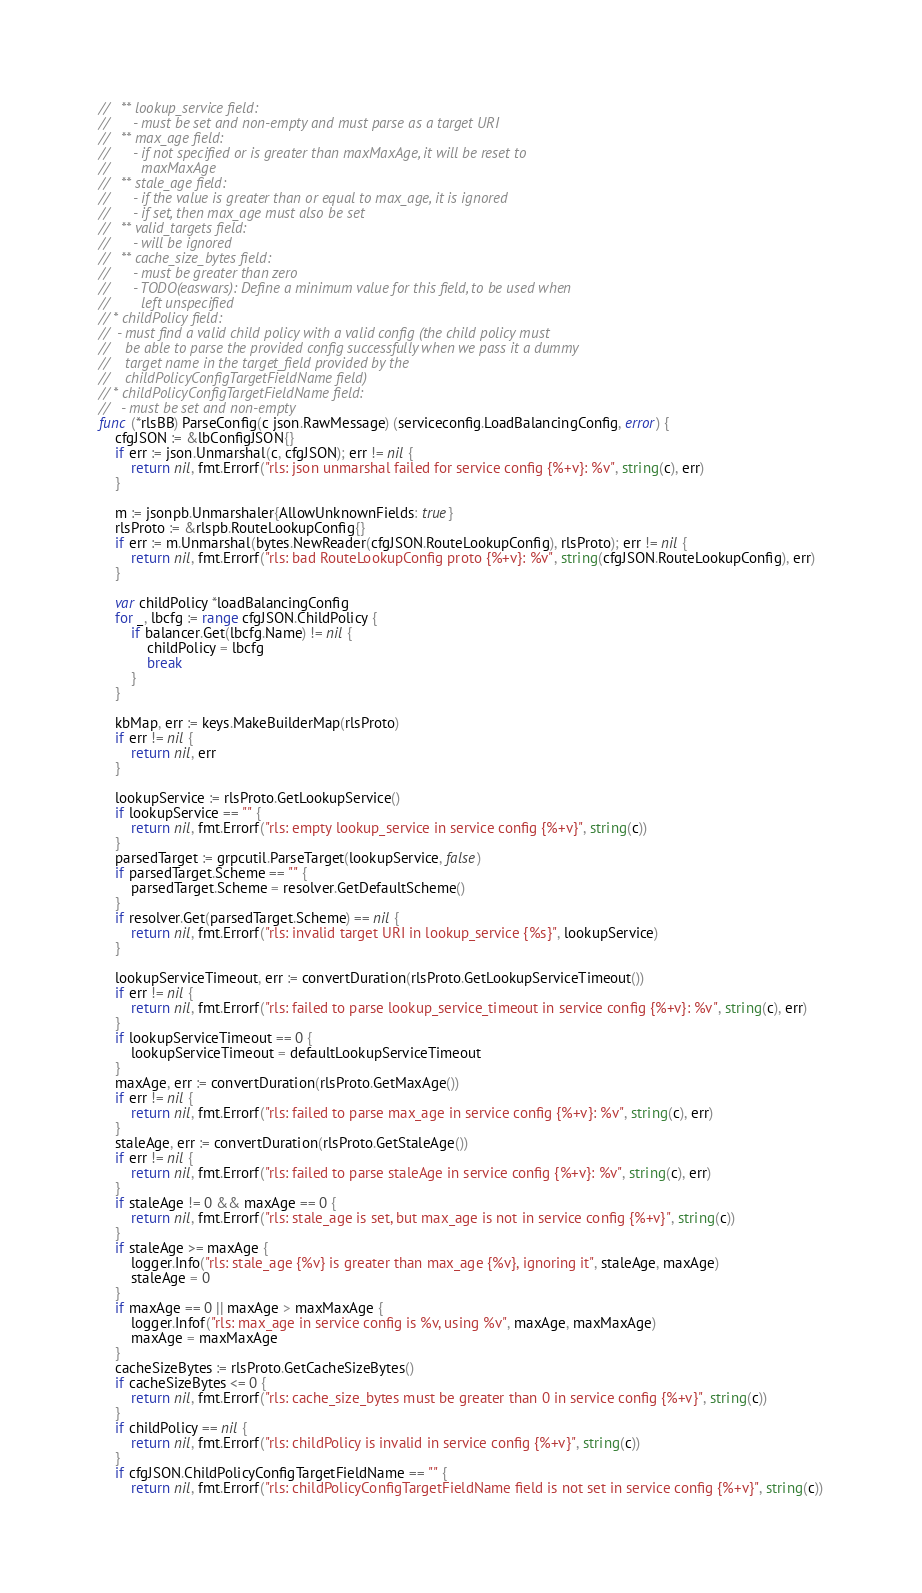Convert code to text. <code><loc_0><loc_0><loc_500><loc_500><_Go_>//   ** lookup_service field:
//      - must be set and non-empty and must parse as a target URI
//   ** max_age field:
//      - if not specified or is greater than maxMaxAge, it will be reset to
//        maxMaxAge
//   ** stale_age field:
//      - if the value is greater than or equal to max_age, it is ignored
//      - if set, then max_age must also be set
//   ** valid_targets field:
//      - will be ignored
//   ** cache_size_bytes field:
//      - must be greater than zero
//      - TODO(easwars): Define a minimum value for this field, to be used when
//        left unspecified
// * childPolicy field:
//  - must find a valid child policy with a valid config (the child policy must
//    be able to parse the provided config successfully when we pass it a dummy
//    target name in the target_field provided by the
//    childPolicyConfigTargetFieldName field)
// * childPolicyConfigTargetFieldName field:
//   - must be set and non-empty
func (*rlsBB) ParseConfig(c json.RawMessage) (serviceconfig.LoadBalancingConfig, error) {
	cfgJSON := &lbConfigJSON{}
	if err := json.Unmarshal(c, cfgJSON); err != nil {
		return nil, fmt.Errorf("rls: json unmarshal failed for service config {%+v}: %v", string(c), err)
	}

	m := jsonpb.Unmarshaler{AllowUnknownFields: true}
	rlsProto := &rlspb.RouteLookupConfig{}
	if err := m.Unmarshal(bytes.NewReader(cfgJSON.RouteLookupConfig), rlsProto); err != nil {
		return nil, fmt.Errorf("rls: bad RouteLookupConfig proto {%+v}: %v", string(cfgJSON.RouteLookupConfig), err)
	}

	var childPolicy *loadBalancingConfig
	for _, lbcfg := range cfgJSON.ChildPolicy {
		if balancer.Get(lbcfg.Name) != nil {
			childPolicy = lbcfg
			break
		}
	}

	kbMap, err := keys.MakeBuilderMap(rlsProto)
	if err != nil {
		return nil, err
	}

	lookupService := rlsProto.GetLookupService()
	if lookupService == "" {
		return nil, fmt.Errorf("rls: empty lookup_service in service config {%+v}", string(c))
	}
	parsedTarget := grpcutil.ParseTarget(lookupService, false)
	if parsedTarget.Scheme == "" {
		parsedTarget.Scheme = resolver.GetDefaultScheme()
	}
	if resolver.Get(parsedTarget.Scheme) == nil {
		return nil, fmt.Errorf("rls: invalid target URI in lookup_service {%s}", lookupService)
	}

	lookupServiceTimeout, err := convertDuration(rlsProto.GetLookupServiceTimeout())
	if err != nil {
		return nil, fmt.Errorf("rls: failed to parse lookup_service_timeout in service config {%+v}: %v", string(c), err)
	}
	if lookupServiceTimeout == 0 {
		lookupServiceTimeout = defaultLookupServiceTimeout
	}
	maxAge, err := convertDuration(rlsProto.GetMaxAge())
	if err != nil {
		return nil, fmt.Errorf("rls: failed to parse max_age in service config {%+v}: %v", string(c), err)
	}
	staleAge, err := convertDuration(rlsProto.GetStaleAge())
	if err != nil {
		return nil, fmt.Errorf("rls: failed to parse staleAge in service config {%+v}: %v", string(c), err)
	}
	if staleAge != 0 && maxAge == 0 {
		return nil, fmt.Errorf("rls: stale_age is set, but max_age is not in service config {%+v}", string(c))
	}
	if staleAge >= maxAge {
		logger.Info("rls: stale_age {%v} is greater than max_age {%v}, ignoring it", staleAge, maxAge)
		staleAge = 0
	}
	if maxAge == 0 || maxAge > maxMaxAge {
		logger.Infof("rls: max_age in service config is %v, using %v", maxAge, maxMaxAge)
		maxAge = maxMaxAge
	}
	cacheSizeBytes := rlsProto.GetCacheSizeBytes()
	if cacheSizeBytes <= 0 {
		return nil, fmt.Errorf("rls: cache_size_bytes must be greater than 0 in service config {%+v}", string(c))
	}
	if childPolicy == nil {
		return nil, fmt.Errorf("rls: childPolicy is invalid in service config {%+v}", string(c))
	}
	if cfgJSON.ChildPolicyConfigTargetFieldName == "" {
		return nil, fmt.Errorf("rls: childPolicyConfigTargetFieldName field is not set in service config {%+v}", string(c))</code> 